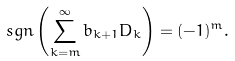Convert formula to latex. <formula><loc_0><loc_0><loc_500><loc_500>\ s g n \left ( \sum _ { k = m } ^ { \infty } b _ { k + 1 } D _ { k } \right ) = ( - 1 ) ^ { m } .</formula> 